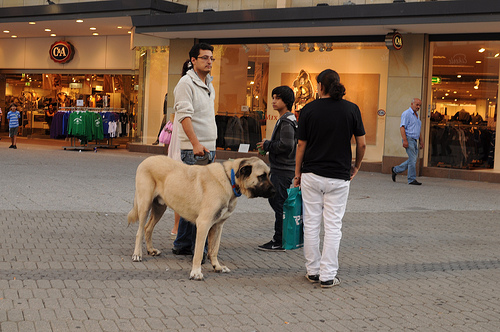Do you see horses or dogs that are large? Yes, there are large dogs present in the scene, but no horses are visible in the image. 